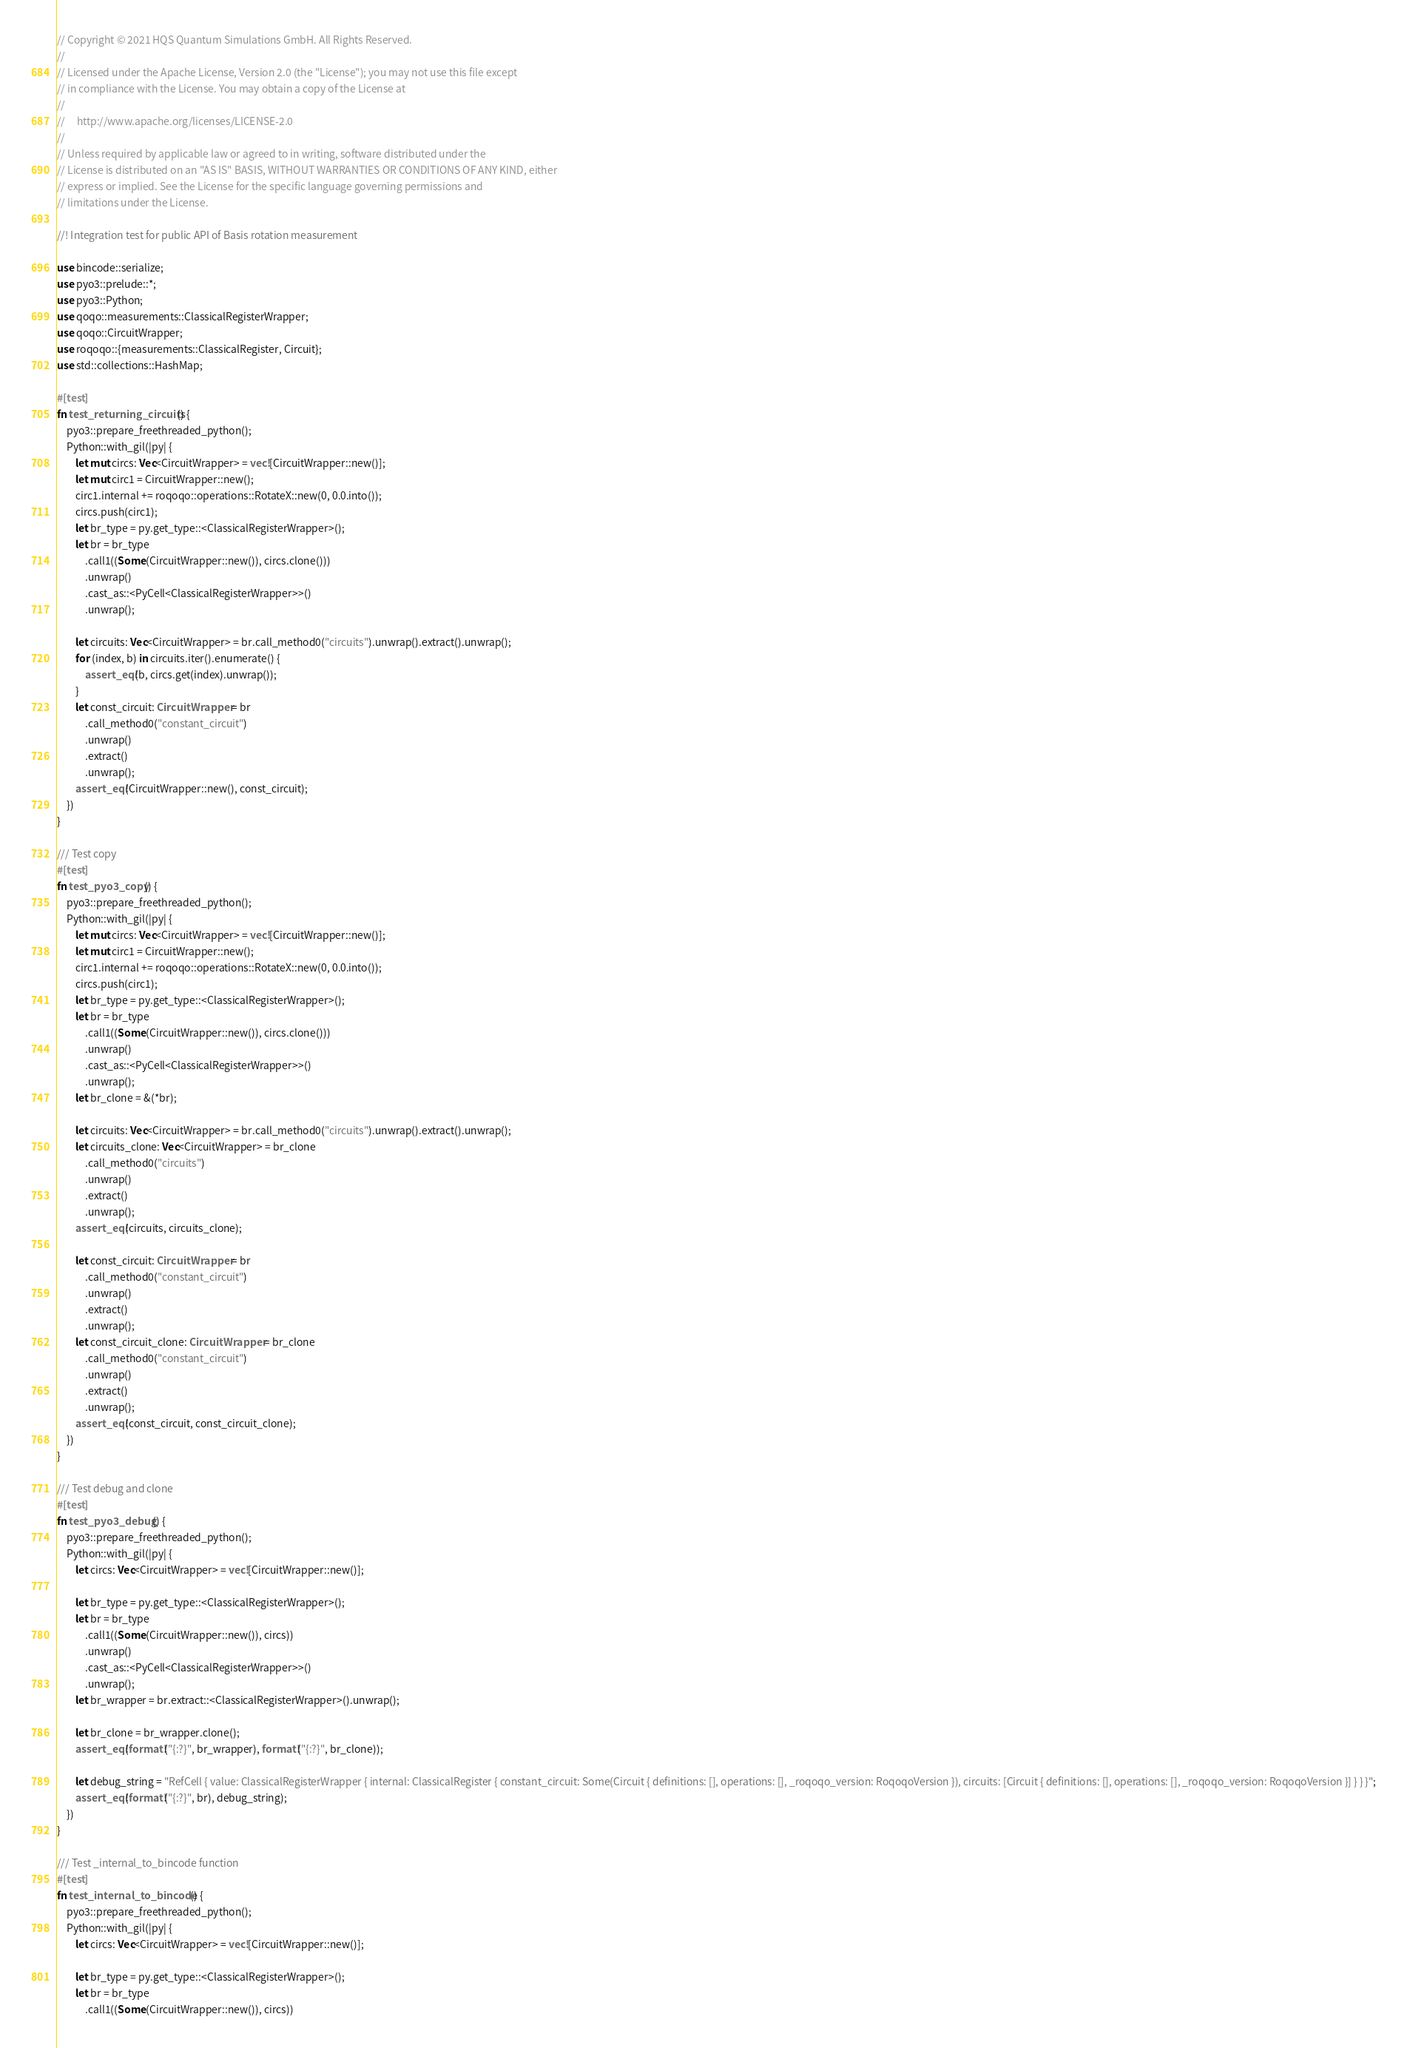<code> <loc_0><loc_0><loc_500><loc_500><_Rust_>// Copyright © 2021 HQS Quantum Simulations GmbH. All Rights Reserved.
//
// Licensed under the Apache License, Version 2.0 (the "License"); you may not use this file except
// in compliance with the License. You may obtain a copy of the License at
//
//     http://www.apache.org/licenses/LICENSE-2.0
//
// Unless required by applicable law or agreed to in writing, software distributed under the
// License is distributed on an "AS IS" BASIS, WITHOUT WARRANTIES OR CONDITIONS OF ANY KIND, either
// express or implied. See the License for the specific language governing permissions and
// limitations under the License.

//! Integration test for public API of Basis rotation measurement

use bincode::serialize;
use pyo3::prelude::*;
use pyo3::Python;
use qoqo::measurements::ClassicalRegisterWrapper;
use qoqo::CircuitWrapper;
use roqoqo::{measurements::ClassicalRegister, Circuit};
use std::collections::HashMap;

#[test]
fn test_returning_circuits() {
    pyo3::prepare_freethreaded_python();
    Python::with_gil(|py| {
        let mut circs: Vec<CircuitWrapper> = vec![CircuitWrapper::new()];
        let mut circ1 = CircuitWrapper::new();
        circ1.internal += roqoqo::operations::RotateX::new(0, 0.0.into());
        circs.push(circ1);
        let br_type = py.get_type::<ClassicalRegisterWrapper>();
        let br = br_type
            .call1((Some(CircuitWrapper::new()), circs.clone()))
            .unwrap()
            .cast_as::<PyCell<ClassicalRegisterWrapper>>()
            .unwrap();

        let circuits: Vec<CircuitWrapper> = br.call_method0("circuits").unwrap().extract().unwrap();
        for (index, b) in circuits.iter().enumerate() {
            assert_eq!(b, circs.get(index).unwrap());
        }
        let const_circuit: CircuitWrapper = br
            .call_method0("constant_circuit")
            .unwrap()
            .extract()
            .unwrap();
        assert_eq!(CircuitWrapper::new(), const_circuit);
    })
}

/// Test copy
#[test]
fn test_pyo3_copy() {
    pyo3::prepare_freethreaded_python();
    Python::with_gil(|py| {
        let mut circs: Vec<CircuitWrapper> = vec![CircuitWrapper::new()];
        let mut circ1 = CircuitWrapper::new();
        circ1.internal += roqoqo::operations::RotateX::new(0, 0.0.into());
        circs.push(circ1);
        let br_type = py.get_type::<ClassicalRegisterWrapper>();
        let br = br_type
            .call1((Some(CircuitWrapper::new()), circs.clone()))
            .unwrap()
            .cast_as::<PyCell<ClassicalRegisterWrapper>>()
            .unwrap();
        let br_clone = &(*br);

        let circuits: Vec<CircuitWrapper> = br.call_method0("circuits").unwrap().extract().unwrap();
        let circuits_clone: Vec<CircuitWrapper> = br_clone
            .call_method0("circuits")
            .unwrap()
            .extract()
            .unwrap();
        assert_eq!(circuits, circuits_clone);

        let const_circuit: CircuitWrapper = br
            .call_method0("constant_circuit")
            .unwrap()
            .extract()
            .unwrap();
        let const_circuit_clone: CircuitWrapper = br_clone
            .call_method0("constant_circuit")
            .unwrap()
            .extract()
            .unwrap();
        assert_eq!(const_circuit, const_circuit_clone);
    })
}

/// Test debug and clone
#[test]
fn test_pyo3_debug() {
    pyo3::prepare_freethreaded_python();
    Python::with_gil(|py| {
        let circs: Vec<CircuitWrapper> = vec![CircuitWrapper::new()];

        let br_type = py.get_type::<ClassicalRegisterWrapper>();
        let br = br_type
            .call1((Some(CircuitWrapper::new()), circs))
            .unwrap()
            .cast_as::<PyCell<ClassicalRegisterWrapper>>()
            .unwrap();
        let br_wrapper = br.extract::<ClassicalRegisterWrapper>().unwrap();

        let br_clone = br_wrapper.clone();
        assert_eq!(format!("{:?}", br_wrapper), format!("{:?}", br_clone));

        let debug_string = "RefCell { value: ClassicalRegisterWrapper { internal: ClassicalRegister { constant_circuit: Some(Circuit { definitions: [], operations: [], _roqoqo_version: RoqoqoVersion }), circuits: [Circuit { definitions: [], operations: [], _roqoqo_version: RoqoqoVersion }] } } }";
        assert_eq!(format!("{:?}", br), debug_string);
    })
}

/// Test _internal_to_bincode function
#[test]
fn test_internal_to_bincode() {
    pyo3::prepare_freethreaded_python();
    Python::with_gil(|py| {
        let circs: Vec<CircuitWrapper> = vec![CircuitWrapper::new()];

        let br_type = py.get_type::<ClassicalRegisterWrapper>();
        let br = br_type
            .call1((Some(CircuitWrapper::new()), circs))</code> 